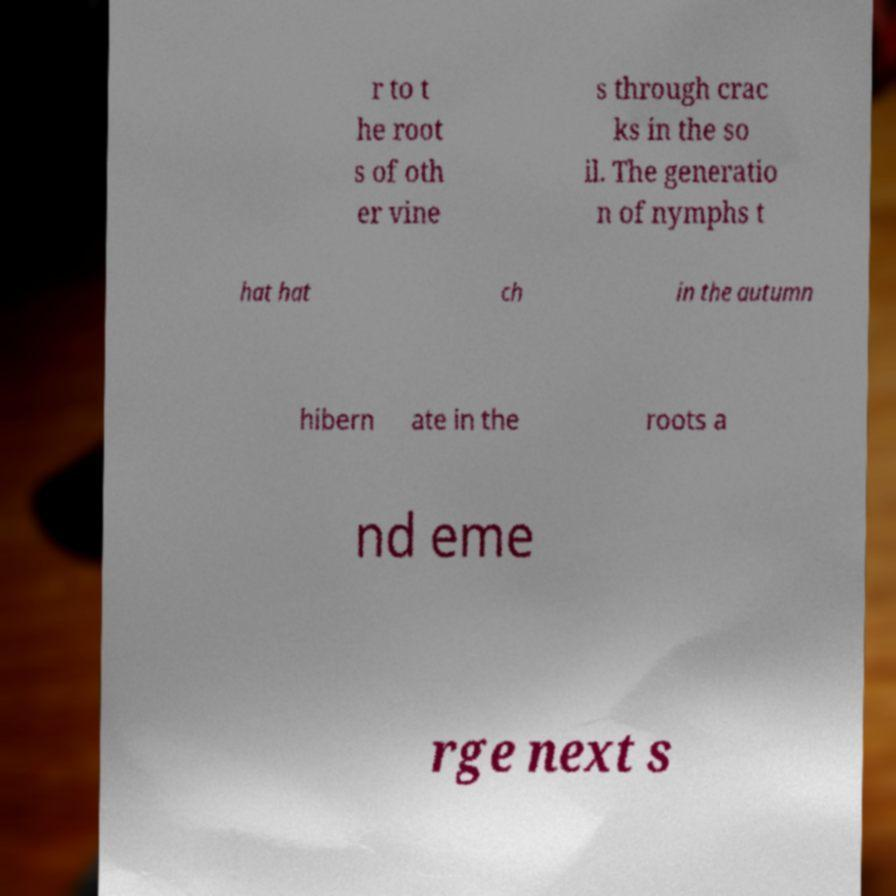I need the written content from this picture converted into text. Can you do that? r to t he root s of oth er vine s through crac ks in the so il. The generatio n of nymphs t hat hat ch in the autumn hibern ate in the roots a nd eme rge next s 